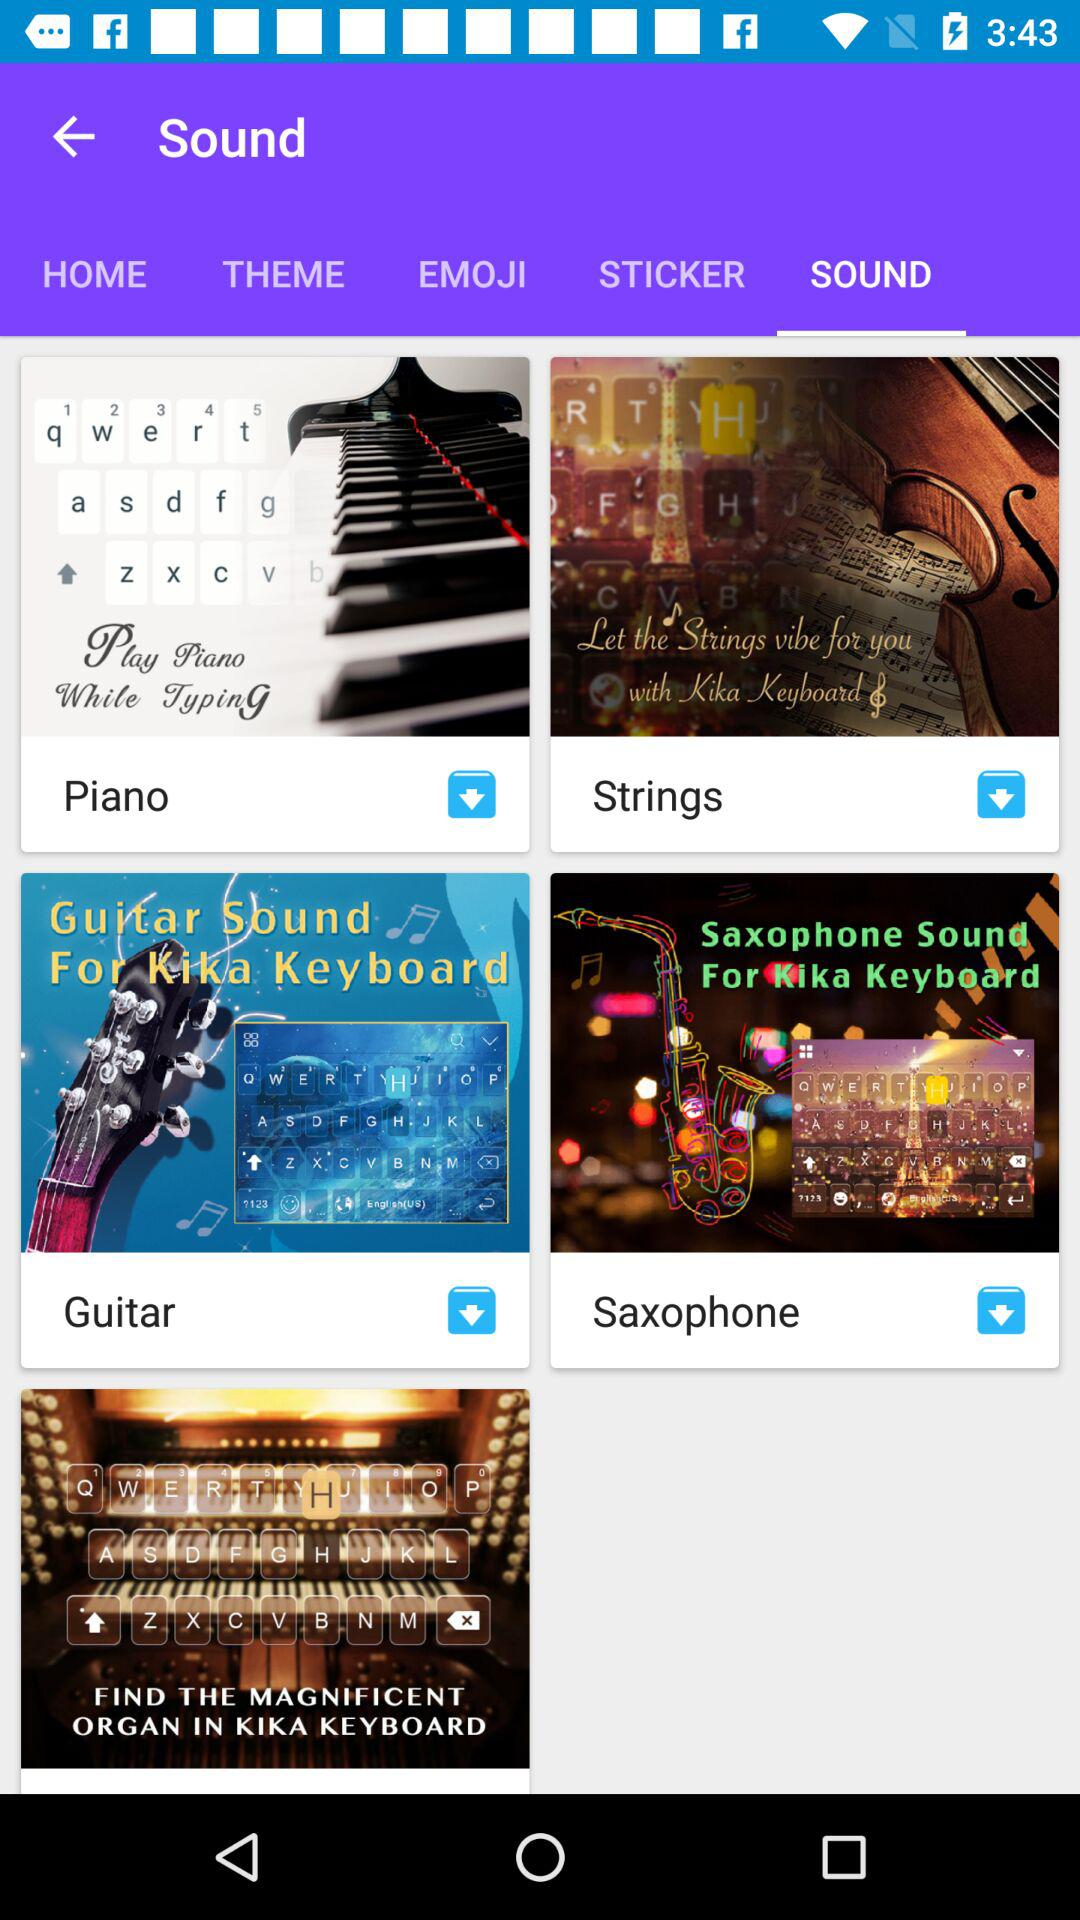Which tab is selected? The selected tab is "SOUND". 